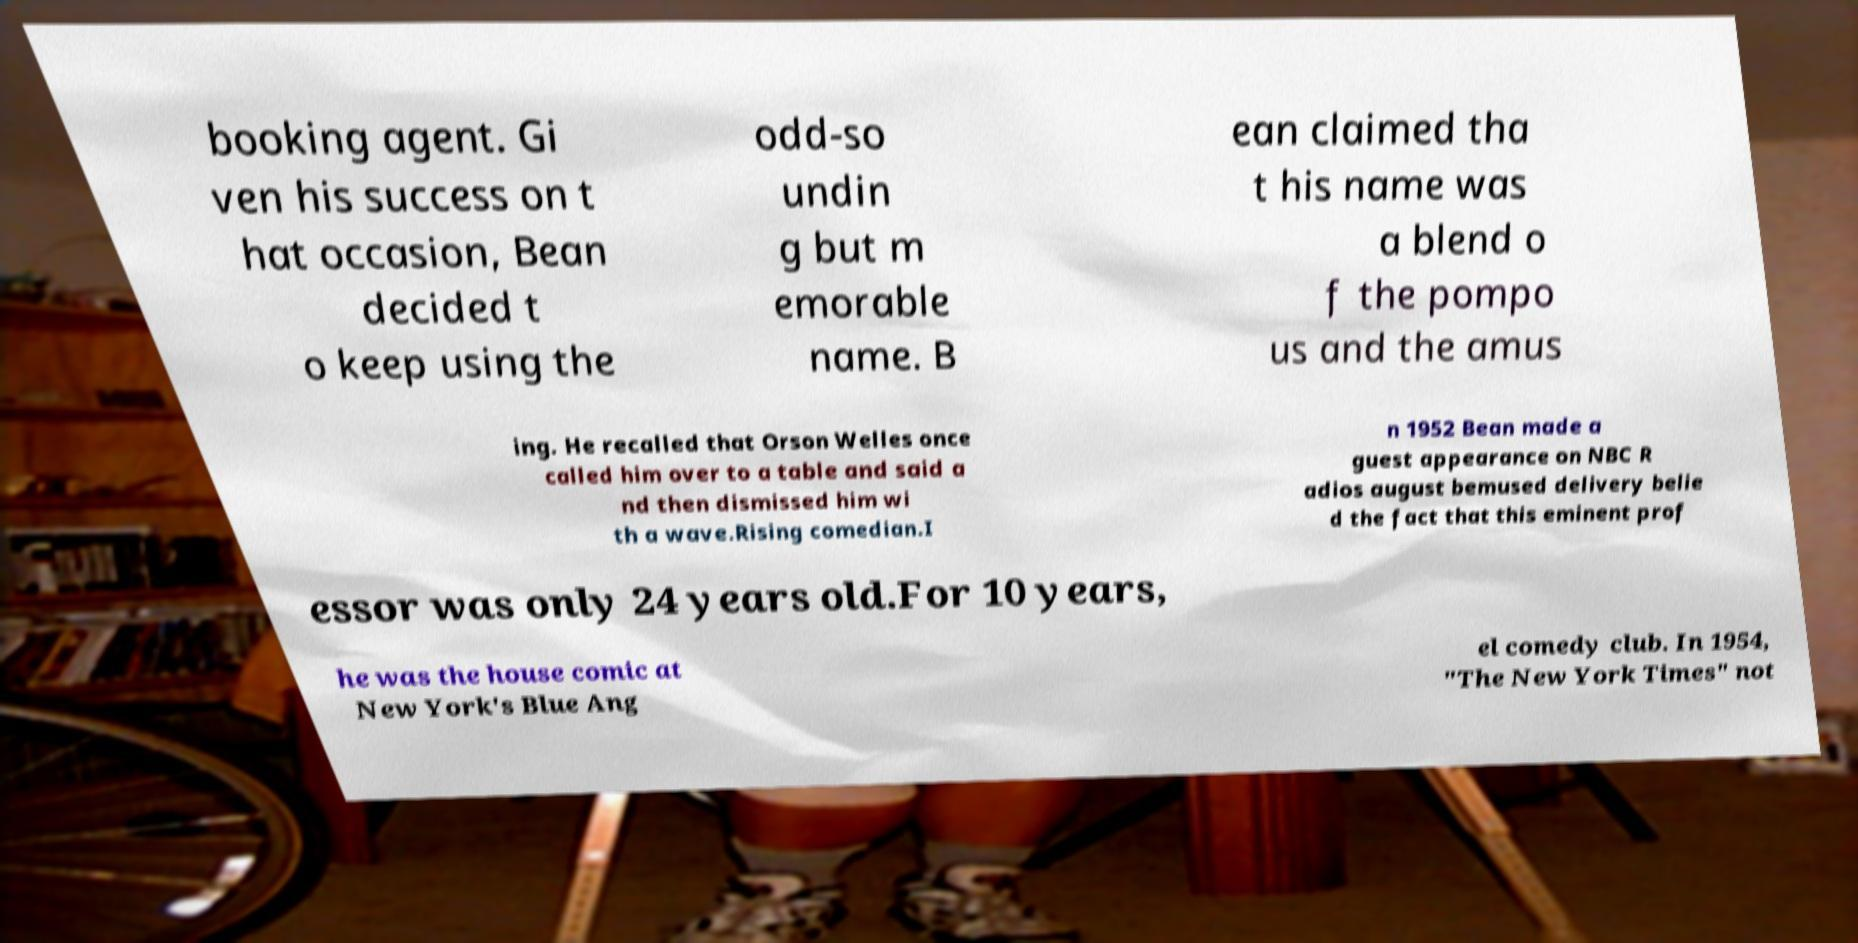Could you extract and type out the text from this image? booking agent. Gi ven his success on t hat occasion, Bean decided t o keep using the odd-so undin g but m emorable name. B ean claimed tha t his name was a blend o f the pompo us and the amus ing. He recalled that Orson Welles once called him over to a table and said a nd then dismissed him wi th a wave.Rising comedian.I n 1952 Bean made a guest appearance on NBC R adios august bemused delivery belie d the fact that this eminent prof essor was only 24 years old.For 10 years, he was the house comic at New York's Blue Ang el comedy club. In 1954, "The New York Times" not 